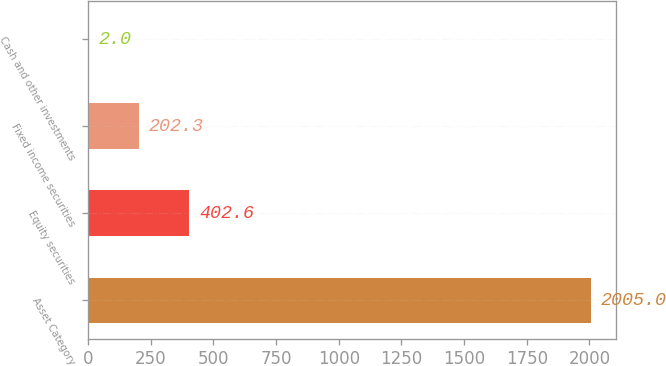Convert chart to OTSL. <chart><loc_0><loc_0><loc_500><loc_500><bar_chart><fcel>Asset Category<fcel>Equity securities<fcel>Fixed income securities<fcel>Cash and other investments<nl><fcel>2005<fcel>402.6<fcel>202.3<fcel>2<nl></chart> 